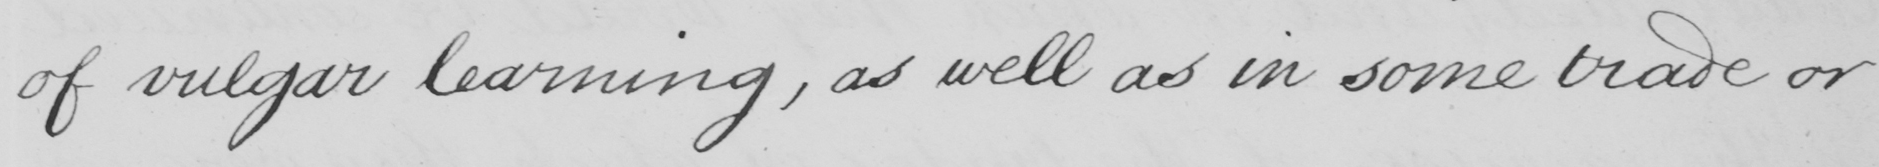Please transcribe the handwritten text in this image. of vulgar learning , as well as in some trade or 